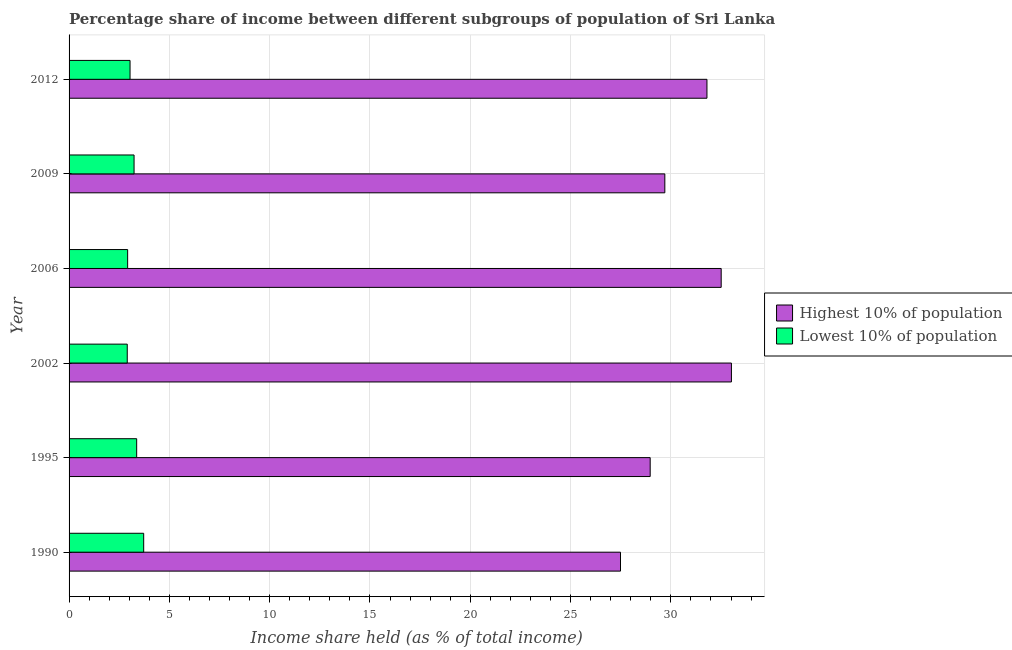How many different coloured bars are there?
Give a very brief answer. 2. Are the number of bars per tick equal to the number of legend labels?
Ensure brevity in your answer.  Yes. How many bars are there on the 6th tick from the top?
Give a very brief answer. 2. What is the label of the 3rd group of bars from the top?
Your answer should be compact. 2006. What is the income share held by lowest 10% of the population in 2009?
Keep it short and to the point. 3.24. Across all years, what is the maximum income share held by highest 10% of the population?
Your response must be concise. 33.02. Across all years, what is the minimum income share held by highest 10% of the population?
Keep it short and to the point. 27.49. In which year was the income share held by lowest 10% of the population minimum?
Your answer should be compact. 2002. What is the total income share held by lowest 10% of the population in the graph?
Provide a short and direct response. 19.19. What is the difference between the income share held by lowest 10% of the population in 2002 and that in 2012?
Give a very brief answer. -0.14. What is the difference between the income share held by highest 10% of the population in 1990 and the income share held by lowest 10% of the population in 2009?
Your answer should be compact. 24.25. What is the average income share held by highest 10% of the population per year?
Keep it short and to the point. 30.58. In the year 2006, what is the difference between the income share held by highest 10% of the population and income share held by lowest 10% of the population?
Make the answer very short. 29.59. What is the ratio of the income share held by highest 10% of the population in 1995 to that in 2006?
Make the answer very short. 0.89. Is the income share held by lowest 10% of the population in 1990 less than that in 2012?
Ensure brevity in your answer.  No. Is the difference between the income share held by lowest 10% of the population in 1990 and 1995 greater than the difference between the income share held by highest 10% of the population in 1990 and 1995?
Your answer should be very brief. Yes. What is the difference between the highest and the second highest income share held by highest 10% of the population?
Give a very brief answer. 0.51. What is the difference between the highest and the lowest income share held by highest 10% of the population?
Your answer should be very brief. 5.53. In how many years, is the income share held by highest 10% of the population greater than the average income share held by highest 10% of the population taken over all years?
Your response must be concise. 3. Is the sum of the income share held by highest 10% of the population in 1990 and 2009 greater than the maximum income share held by lowest 10% of the population across all years?
Provide a succinct answer. Yes. What does the 2nd bar from the top in 2012 represents?
Offer a terse response. Highest 10% of population. What does the 1st bar from the bottom in 1990 represents?
Ensure brevity in your answer.  Highest 10% of population. Are all the bars in the graph horizontal?
Give a very brief answer. Yes. How many years are there in the graph?
Make the answer very short. 6. What is the difference between two consecutive major ticks on the X-axis?
Your answer should be compact. 5. Are the values on the major ticks of X-axis written in scientific E-notation?
Provide a succinct answer. No. Does the graph contain any zero values?
Provide a succinct answer. No. Where does the legend appear in the graph?
Give a very brief answer. Center right. How many legend labels are there?
Offer a terse response. 2. How are the legend labels stacked?
Provide a short and direct response. Vertical. What is the title of the graph?
Offer a very short reply. Percentage share of income between different subgroups of population of Sri Lanka. What is the label or title of the X-axis?
Provide a succinct answer. Income share held (as % of total income). What is the Income share held (as % of total income) in Highest 10% of population in 1990?
Your answer should be very brief. 27.49. What is the Income share held (as % of total income) of Lowest 10% of population in 1990?
Provide a succinct answer. 3.72. What is the Income share held (as % of total income) of Highest 10% of population in 1995?
Ensure brevity in your answer.  28.97. What is the Income share held (as % of total income) of Lowest 10% of population in 1995?
Your response must be concise. 3.37. What is the Income share held (as % of total income) of Highest 10% of population in 2002?
Your answer should be compact. 33.02. What is the Income share held (as % of total income) of Highest 10% of population in 2006?
Provide a succinct answer. 32.51. What is the Income share held (as % of total income) of Lowest 10% of population in 2006?
Offer a terse response. 2.92. What is the Income share held (as % of total income) in Highest 10% of population in 2009?
Offer a terse response. 29.7. What is the Income share held (as % of total income) in Lowest 10% of population in 2009?
Offer a terse response. 3.24. What is the Income share held (as % of total income) of Highest 10% of population in 2012?
Your response must be concise. 31.8. What is the Income share held (as % of total income) of Lowest 10% of population in 2012?
Your answer should be very brief. 3.04. Across all years, what is the maximum Income share held (as % of total income) of Highest 10% of population?
Your response must be concise. 33.02. Across all years, what is the maximum Income share held (as % of total income) in Lowest 10% of population?
Provide a short and direct response. 3.72. Across all years, what is the minimum Income share held (as % of total income) of Highest 10% of population?
Offer a very short reply. 27.49. Across all years, what is the minimum Income share held (as % of total income) of Lowest 10% of population?
Your response must be concise. 2.9. What is the total Income share held (as % of total income) of Highest 10% of population in the graph?
Your answer should be very brief. 183.49. What is the total Income share held (as % of total income) of Lowest 10% of population in the graph?
Offer a very short reply. 19.19. What is the difference between the Income share held (as % of total income) in Highest 10% of population in 1990 and that in 1995?
Offer a terse response. -1.48. What is the difference between the Income share held (as % of total income) in Highest 10% of population in 1990 and that in 2002?
Provide a short and direct response. -5.53. What is the difference between the Income share held (as % of total income) in Lowest 10% of population in 1990 and that in 2002?
Keep it short and to the point. 0.82. What is the difference between the Income share held (as % of total income) in Highest 10% of population in 1990 and that in 2006?
Ensure brevity in your answer.  -5.02. What is the difference between the Income share held (as % of total income) in Highest 10% of population in 1990 and that in 2009?
Provide a succinct answer. -2.21. What is the difference between the Income share held (as % of total income) of Lowest 10% of population in 1990 and that in 2009?
Your answer should be compact. 0.48. What is the difference between the Income share held (as % of total income) of Highest 10% of population in 1990 and that in 2012?
Your answer should be compact. -4.31. What is the difference between the Income share held (as % of total income) in Lowest 10% of population in 1990 and that in 2012?
Your answer should be compact. 0.68. What is the difference between the Income share held (as % of total income) in Highest 10% of population in 1995 and that in 2002?
Give a very brief answer. -4.05. What is the difference between the Income share held (as % of total income) in Lowest 10% of population in 1995 and that in 2002?
Your response must be concise. 0.47. What is the difference between the Income share held (as % of total income) in Highest 10% of population in 1995 and that in 2006?
Give a very brief answer. -3.54. What is the difference between the Income share held (as % of total income) in Lowest 10% of population in 1995 and that in 2006?
Offer a terse response. 0.45. What is the difference between the Income share held (as % of total income) in Highest 10% of population in 1995 and that in 2009?
Keep it short and to the point. -0.73. What is the difference between the Income share held (as % of total income) of Lowest 10% of population in 1995 and that in 2009?
Provide a succinct answer. 0.13. What is the difference between the Income share held (as % of total income) of Highest 10% of population in 1995 and that in 2012?
Keep it short and to the point. -2.83. What is the difference between the Income share held (as % of total income) in Lowest 10% of population in 1995 and that in 2012?
Give a very brief answer. 0.33. What is the difference between the Income share held (as % of total income) in Highest 10% of population in 2002 and that in 2006?
Keep it short and to the point. 0.51. What is the difference between the Income share held (as % of total income) of Lowest 10% of population in 2002 and that in 2006?
Your answer should be compact. -0.02. What is the difference between the Income share held (as % of total income) of Highest 10% of population in 2002 and that in 2009?
Your response must be concise. 3.32. What is the difference between the Income share held (as % of total income) of Lowest 10% of population in 2002 and that in 2009?
Your answer should be very brief. -0.34. What is the difference between the Income share held (as % of total income) of Highest 10% of population in 2002 and that in 2012?
Make the answer very short. 1.22. What is the difference between the Income share held (as % of total income) in Lowest 10% of population in 2002 and that in 2012?
Give a very brief answer. -0.14. What is the difference between the Income share held (as % of total income) of Highest 10% of population in 2006 and that in 2009?
Ensure brevity in your answer.  2.81. What is the difference between the Income share held (as % of total income) in Lowest 10% of population in 2006 and that in 2009?
Give a very brief answer. -0.32. What is the difference between the Income share held (as % of total income) in Highest 10% of population in 2006 and that in 2012?
Your answer should be very brief. 0.71. What is the difference between the Income share held (as % of total income) of Lowest 10% of population in 2006 and that in 2012?
Your response must be concise. -0.12. What is the difference between the Income share held (as % of total income) in Highest 10% of population in 1990 and the Income share held (as % of total income) in Lowest 10% of population in 1995?
Give a very brief answer. 24.12. What is the difference between the Income share held (as % of total income) in Highest 10% of population in 1990 and the Income share held (as % of total income) in Lowest 10% of population in 2002?
Offer a very short reply. 24.59. What is the difference between the Income share held (as % of total income) of Highest 10% of population in 1990 and the Income share held (as % of total income) of Lowest 10% of population in 2006?
Provide a succinct answer. 24.57. What is the difference between the Income share held (as % of total income) in Highest 10% of population in 1990 and the Income share held (as % of total income) in Lowest 10% of population in 2009?
Offer a very short reply. 24.25. What is the difference between the Income share held (as % of total income) in Highest 10% of population in 1990 and the Income share held (as % of total income) in Lowest 10% of population in 2012?
Make the answer very short. 24.45. What is the difference between the Income share held (as % of total income) in Highest 10% of population in 1995 and the Income share held (as % of total income) in Lowest 10% of population in 2002?
Your answer should be very brief. 26.07. What is the difference between the Income share held (as % of total income) in Highest 10% of population in 1995 and the Income share held (as % of total income) in Lowest 10% of population in 2006?
Offer a very short reply. 26.05. What is the difference between the Income share held (as % of total income) in Highest 10% of population in 1995 and the Income share held (as % of total income) in Lowest 10% of population in 2009?
Provide a succinct answer. 25.73. What is the difference between the Income share held (as % of total income) of Highest 10% of population in 1995 and the Income share held (as % of total income) of Lowest 10% of population in 2012?
Your response must be concise. 25.93. What is the difference between the Income share held (as % of total income) in Highest 10% of population in 2002 and the Income share held (as % of total income) in Lowest 10% of population in 2006?
Your answer should be very brief. 30.1. What is the difference between the Income share held (as % of total income) of Highest 10% of population in 2002 and the Income share held (as % of total income) of Lowest 10% of population in 2009?
Offer a very short reply. 29.78. What is the difference between the Income share held (as % of total income) in Highest 10% of population in 2002 and the Income share held (as % of total income) in Lowest 10% of population in 2012?
Offer a terse response. 29.98. What is the difference between the Income share held (as % of total income) in Highest 10% of population in 2006 and the Income share held (as % of total income) in Lowest 10% of population in 2009?
Keep it short and to the point. 29.27. What is the difference between the Income share held (as % of total income) in Highest 10% of population in 2006 and the Income share held (as % of total income) in Lowest 10% of population in 2012?
Provide a succinct answer. 29.47. What is the difference between the Income share held (as % of total income) in Highest 10% of population in 2009 and the Income share held (as % of total income) in Lowest 10% of population in 2012?
Your answer should be compact. 26.66. What is the average Income share held (as % of total income) of Highest 10% of population per year?
Give a very brief answer. 30.58. What is the average Income share held (as % of total income) in Lowest 10% of population per year?
Your answer should be compact. 3.2. In the year 1990, what is the difference between the Income share held (as % of total income) of Highest 10% of population and Income share held (as % of total income) of Lowest 10% of population?
Your response must be concise. 23.77. In the year 1995, what is the difference between the Income share held (as % of total income) of Highest 10% of population and Income share held (as % of total income) of Lowest 10% of population?
Your answer should be compact. 25.6. In the year 2002, what is the difference between the Income share held (as % of total income) in Highest 10% of population and Income share held (as % of total income) in Lowest 10% of population?
Your answer should be compact. 30.12. In the year 2006, what is the difference between the Income share held (as % of total income) of Highest 10% of population and Income share held (as % of total income) of Lowest 10% of population?
Offer a very short reply. 29.59. In the year 2009, what is the difference between the Income share held (as % of total income) in Highest 10% of population and Income share held (as % of total income) in Lowest 10% of population?
Offer a very short reply. 26.46. In the year 2012, what is the difference between the Income share held (as % of total income) in Highest 10% of population and Income share held (as % of total income) in Lowest 10% of population?
Offer a terse response. 28.76. What is the ratio of the Income share held (as % of total income) of Highest 10% of population in 1990 to that in 1995?
Offer a terse response. 0.95. What is the ratio of the Income share held (as % of total income) in Lowest 10% of population in 1990 to that in 1995?
Offer a very short reply. 1.1. What is the ratio of the Income share held (as % of total income) of Highest 10% of population in 1990 to that in 2002?
Provide a short and direct response. 0.83. What is the ratio of the Income share held (as % of total income) in Lowest 10% of population in 1990 to that in 2002?
Your answer should be compact. 1.28. What is the ratio of the Income share held (as % of total income) in Highest 10% of population in 1990 to that in 2006?
Offer a terse response. 0.85. What is the ratio of the Income share held (as % of total income) in Lowest 10% of population in 1990 to that in 2006?
Your answer should be compact. 1.27. What is the ratio of the Income share held (as % of total income) of Highest 10% of population in 1990 to that in 2009?
Offer a very short reply. 0.93. What is the ratio of the Income share held (as % of total income) in Lowest 10% of population in 1990 to that in 2009?
Offer a very short reply. 1.15. What is the ratio of the Income share held (as % of total income) in Highest 10% of population in 1990 to that in 2012?
Make the answer very short. 0.86. What is the ratio of the Income share held (as % of total income) of Lowest 10% of population in 1990 to that in 2012?
Your response must be concise. 1.22. What is the ratio of the Income share held (as % of total income) of Highest 10% of population in 1995 to that in 2002?
Keep it short and to the point. 0.88. What is the ratio of the Income share held (as % of total income) in Lowest 10% of population in 1995 to that in 2002?
Ensure brevity in your answer.  1.16. What is the ratio of the Income share held (as % of total income) in Highest 10% of population in 1995 to that in 2006?
Keep it short and to the point. 0.89. What is the ratio of the Income share held (as % of total income) of Lowest 10% of population in 1995 to that in 2006?
Provide a short and direct response. 1.15. What is the ratio of the Income share held (as % of total income) in Highest 10% of population in 1995 to that in 2009?
Provide a short and direct response. 0.98. What is the ratio of the Income share held (as % of total income) in Lowest 10% of population in 1995 to that in 2009?
Offer a terse response. 1.04. What is the ratio of the Income share held (as % of total income) of Highest 10% of population in 1995 to that in 2012?
Provide a short and direct response. 0.91. What is the ratio of the Income share held (as % of total income) of Lowest 10% of population in 1995 to that in 2012?
Make the answer very short. 1.11. What is the ratio of the Income share held (as % of total income) of Highest 10% of population in 2002 to that in 2006?
Offer a very short reply. 1.02. What is the ratio of the Income share held (as % of total income) in Highest 10% of population in 2002 to that in 2009?
Offer a terse response. 1.11. What is the ratio of the Income share held (as % of total income) in Lowest 10% of population in 2002 to that in 2009?
Offer a very short reply. 0.9. What is the ratio of the Income share held (as % of total income) of Highest 10% of population in 2002 to that in 2012?
Your answer should be compact. 1.04. What is the ratio of the Income share held (as % of total income) of Lowest 10% of population in 2002 to that in 2012?
Your response must be concise. 0.95. What is the ratio of the Income share held (as % of total income) in Highest 10% of population in 2006 to that in 2009?
Provide a succinct answer. 1.09. What is the ratio of the Income share held (as % of total income) of Lowest 10% of population in 2006 to that in 2009?
Your answer should be very brief. 0.9. What is the ratio of the Income share held (as % of total income) in Highest 10% of population in 2006 to that in 2012?
Your answer should be compact. 1.02. What is the ratio of the Income share held (as % of total income) of Lowest 10% of population in 2006 to that in 2012?
Your answer should be compact. 0.96. What is the ratio of the Income share held (as % of total income) of Highest 10% of population in 2009 to that in 2012?
Make the answer very short. 0.93. What is the ratio of the Income share held (as % of total income) in Lowest 10% of population in 2009 to that in 2012?
Provide a short and direct response. 1.07. What is the difference between the highest and the second highest Income share held (as % of total income) of Highest 10% of population?
Give a very brief answer. 0.51. What is the difference between the highest and the lowest Income share held (as % of total income) of Highest 10% of population?
Provide a short and direct response. 5.53. What is the difference between the highest and the lowest Income share held (as % of total income) of Lowest 10% of population?
Keep it short and to the point. 0.82. 